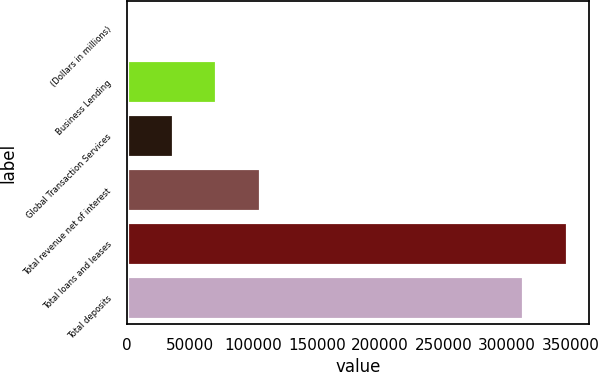Convert chart to OTSL. <chart><loc_0><loc_0><loc_500><loc_500><bar_chart><fcel>(Dollars in millions)<fcel>Business Lending<fcel>Global Transaction Services<fcel>Total revenue net of interest<fcel>Total loans and leases<fcel>Total deposits<nl><fcel>2017<fcel>70828.6<fcel>36422.8<fcel>105234<fcel>347265<fcel>312859<nl></chart> 